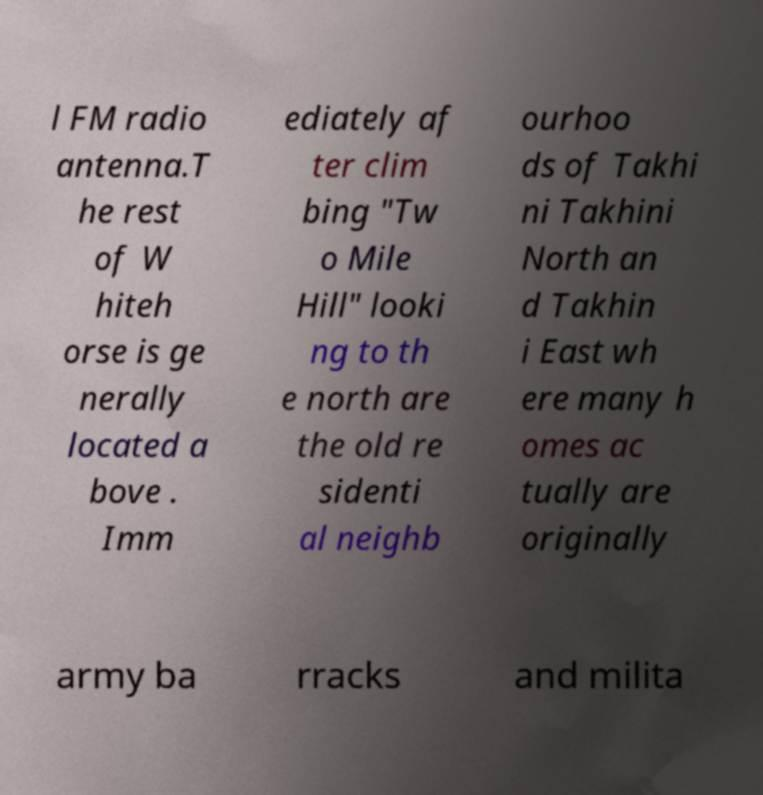Please identify and transcribe the text found in this image. l FM radio antenna.T he rest of W hiteh orse is ge nerally located a bove . Imm ediately af ter clim bing "Tw o Mile Hill" looki ng to th e north are the old re sidenti al neighb ourhoo ds of Takhi ni Takhini North an d Takhin i East wh ere many h omes ac tually are originally army ba rracks and milita 